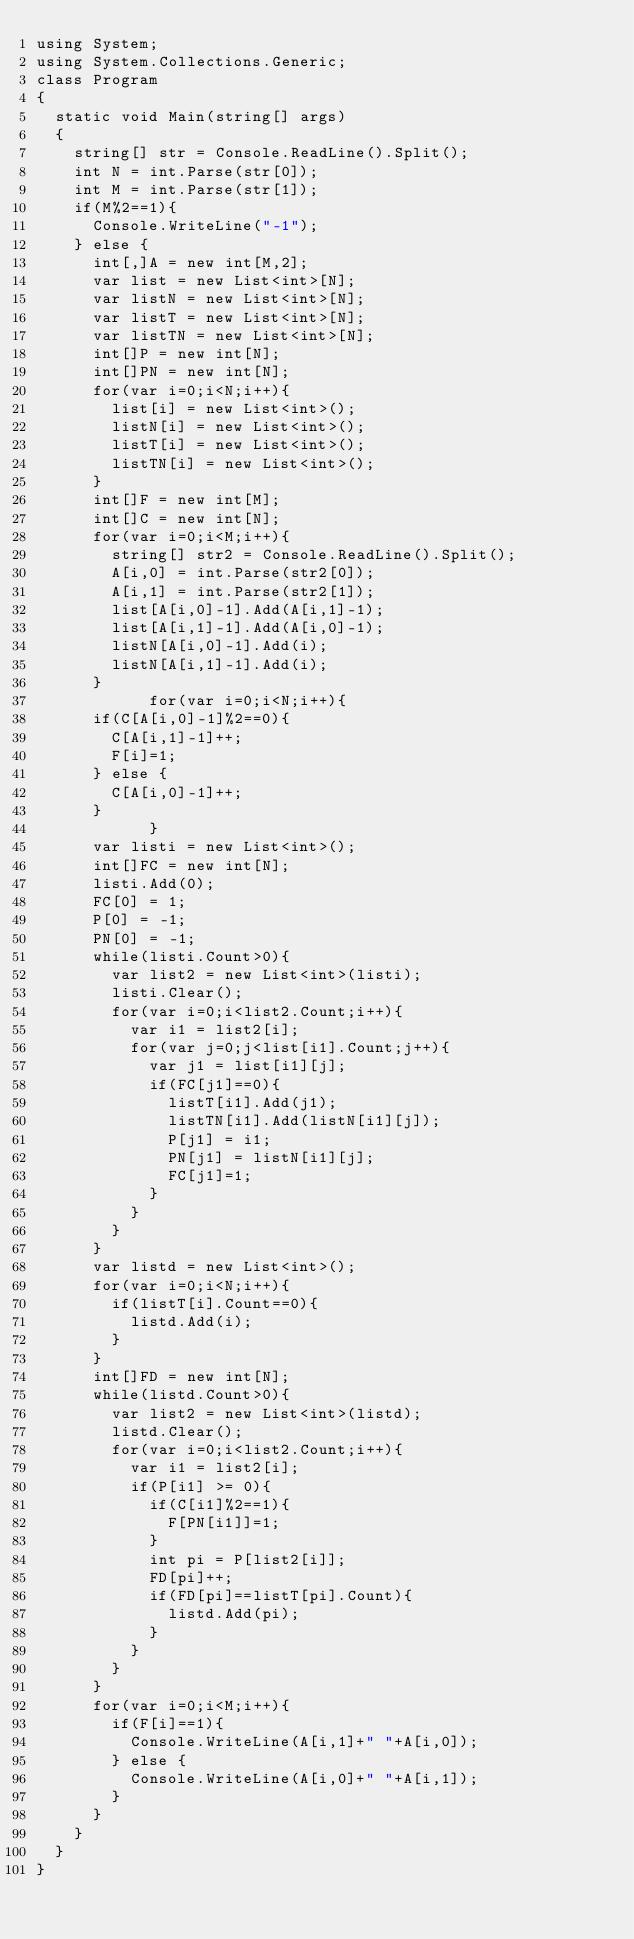Convert code to text. <code><loc_0><loc_0><loc_500><loc_500><_C#_>using System;
using System.Collections.Generic;
class Program
{
	static void Main(string[] args)
	{
		string[] str = Console.ReadLine().Split();
		int N = int.Parse(str[0]);
		int M = int.Parse(str[1]);
		if(M%2==1){
			Console.WriteLine("-1");
		} else {
			int[,]A = new int[M,2];
			var list = new List<int>[N];
			var listN = new List<int>[N];
			var listT = new List<int>[N];
			var listTN = new List<int>[N];
			int[]P = new int[N];
			int[]PN = new int[N];
			for(var i=0;i<N;i++){
				list[i] = new List<int>();
				listN[i] = new List<int>();
				listT[i] = new List<int>();
				listTN[i] = new List<int>();
			}
			int[]F = new int[M];
			int[]C = new int[N];
			for(var i=0;i<M;i++){
				string[] str2 = Console.ReadLine().Split();
				A[i,0] = int.Parse(str2[0]);
				A[i,1] = int.Parse(str2[1]);
				list[A[i,0]-1].Add(A[i,1]-1);
				list[A[i,1]-1].Add(A[i,0]-1);
				listN[A[i,0]-1].Add(i);
				listN[A[i,1]-1].Add(i);
			}
          	for(var i=0;i<N;i++){
			if(C[A[i,0]-1]%2==0){
				C[A[i,1]-1]++;
				F[i]=1;
			} else {
				C[A[i,0]-1]++;
			}
            }
			var listi = new List<int>();
			int[]FC = new int[N];
			listi.Add(0);
			FC[0] = 1;
			P[0] = -1;
			PN[0] = -1;
			while(listi.Count>0){
				var list2 = new List<int>(listi);
				listi.Clear();
				for(var i=0;i<list2.Count;i++){
					var i1 = list2[i];
					for(var j=0;j<list[i1].Count;j++){
						var j1 = list[i1][j];
						if(FC[j1]==0){
							listT[i1].Add(j1);
							listTN[i1].Add(listN[i1][j]);
							P[j1] = i1;
							PN[j1] = listN[i1][j];
							FC[j1]=1;
						}
					}
				}
			}
			var listd = new List<int>();
			for(var i=0;i<N;i++){
				if(listT[i].Count==0){
					listd.Add(i);
				}
			}
			int[]FD = new int[N];
			while(listd.Count>0){
				var list2 = new List<int>(listd);
				listd.Clear();
				for(var i=0;i<list2.Count;i++){
					var i1 = list2[i];
					if(P[i1] >= 0){
						if(C[i1]%2==1){
							F[PN[i1]]=1;
						}
						int pi = P[list2[i]];
						FD[pi]++;
						if(FD[pi]==listT[pi].Count){
							listd.Add(pi);
						}
					}
				}
			}
			for(var i=0;i<M;i++){
				if(F[i]==1){
					Console.WriteLine(A[i,1]+" "+A[i,0]);
				} else {
					Console.WriteLine(A[i,0]+" "+A[i,1]);
				}
			}
		}
	}
}</code> 